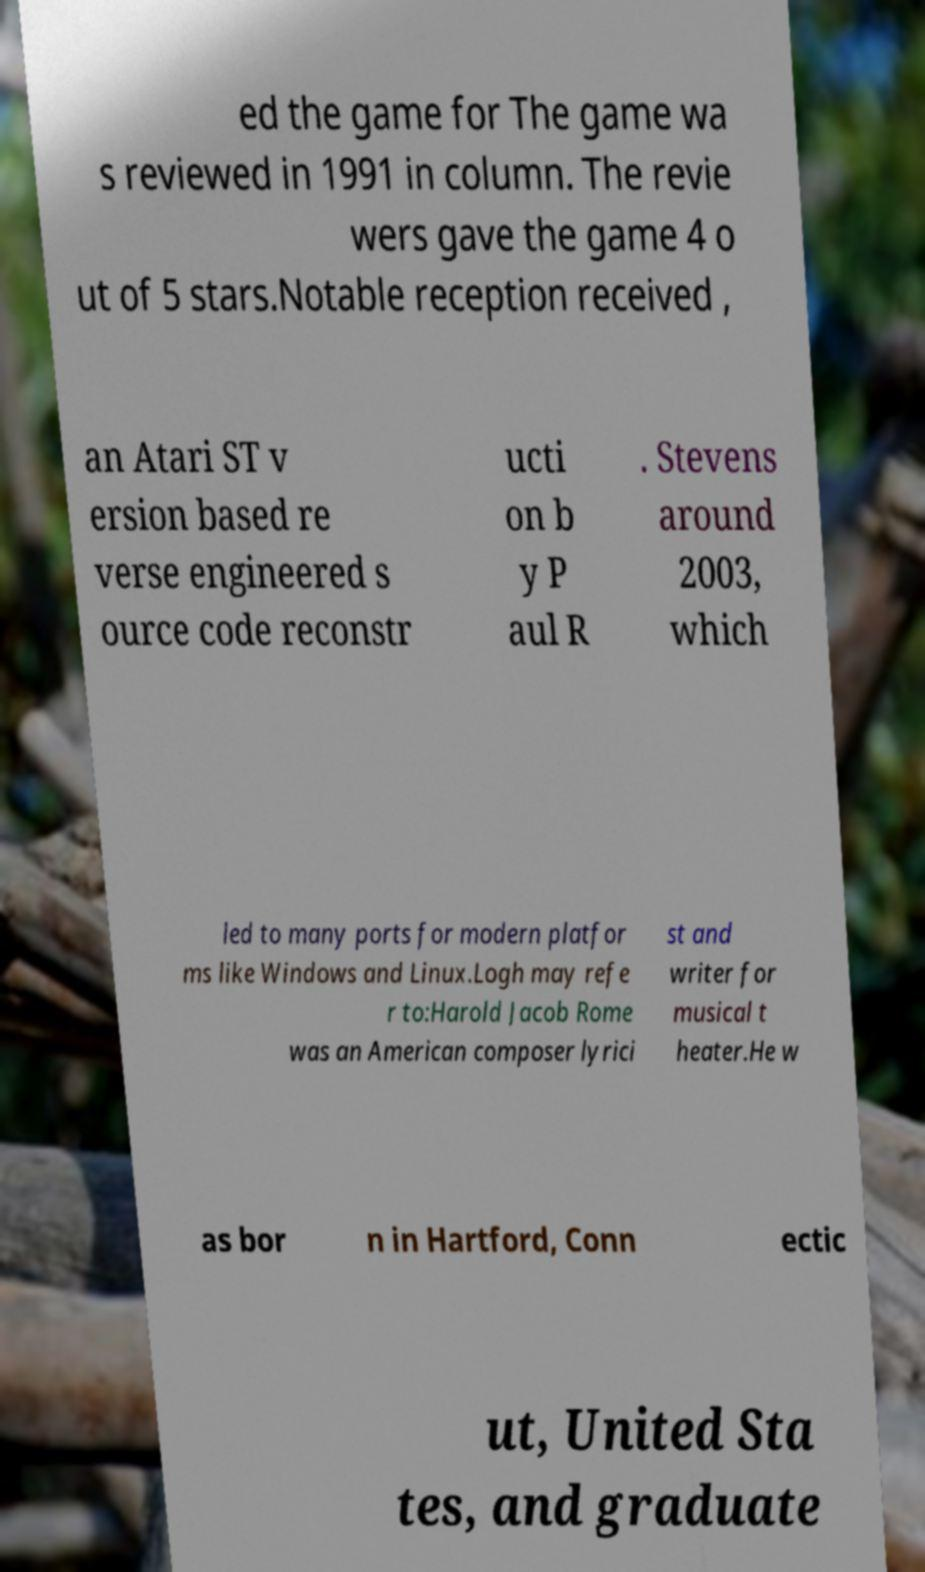Please identify and transcribe the text found in this image. ed the game for The game wa s reviewed in 1991 in column. The revie wers gave the game 4 o ut of 5 stars.Notable reception received , an Atari ST v ersion based re verse engineered s ource code reconstr ucti on b y P aul R . Stevens around 2003, which led to many ports for modern platfor ms like Windows and Linux.Logh may refe r to:Harold Jacob Rome was an American composer lyrici st and writer for musical t heater.He w as bor n in Hartford, Conn ectic ut, United Sta tes, and graduate 